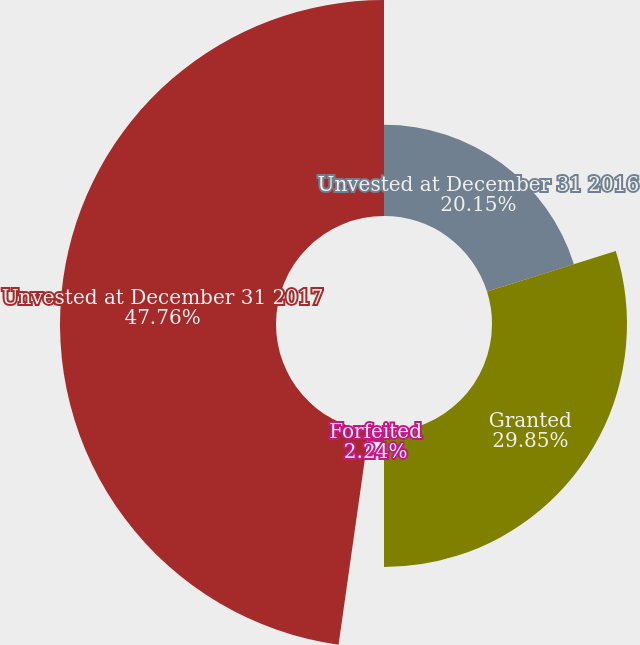Convert chart to OTSL. <chart><loc_0><loc_0><loc_500><loc_500><pie_chart><fcel>Unvested at December 31 2016<fcel>Granted<fcel>Forfeited<fcel>Unvested at December 31 2017<nl><fcel>20.15%<fcel>29.85%<fcel>2.24%<fcel>47.76%<nl></chart> 